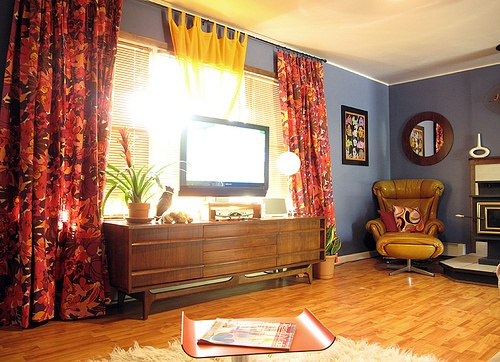Describe the objects in this image and their specific colors. I can see tv in black, white, darkgray, and gray tones, chair in black, brown, maroon, and orange tones, potted plant in black, ivory, olive, khaki, and brown tones, potted plant in black, red, olive, orange, and maroon tones, and vase in black, brown, orange, and salmon tones in this image. 